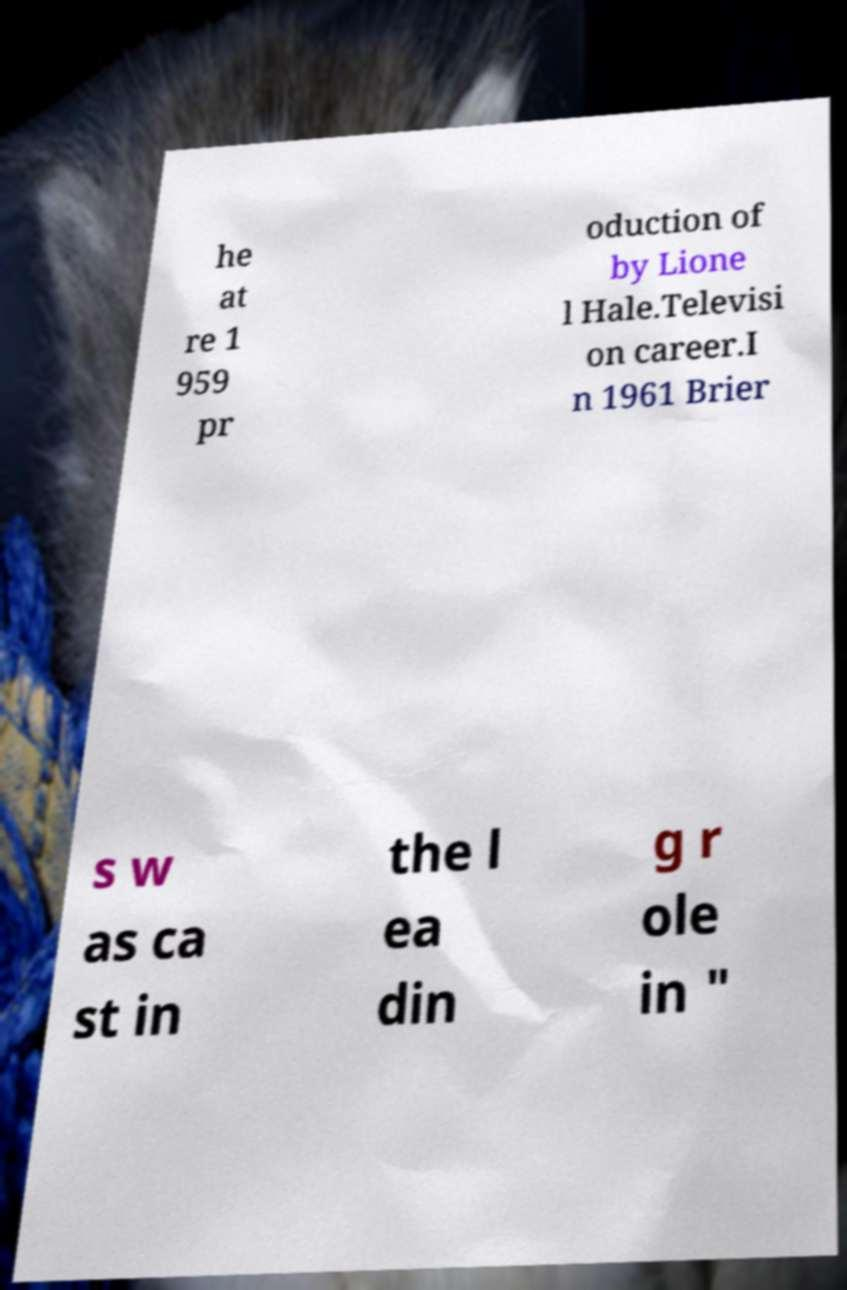Please identify and transcribe the text found in this image. he at re 1 959 pr oduction of by Lione l Hale.Televisi on career.I n 1961 Brier s w as ca st in the l ea din g r ole in " 